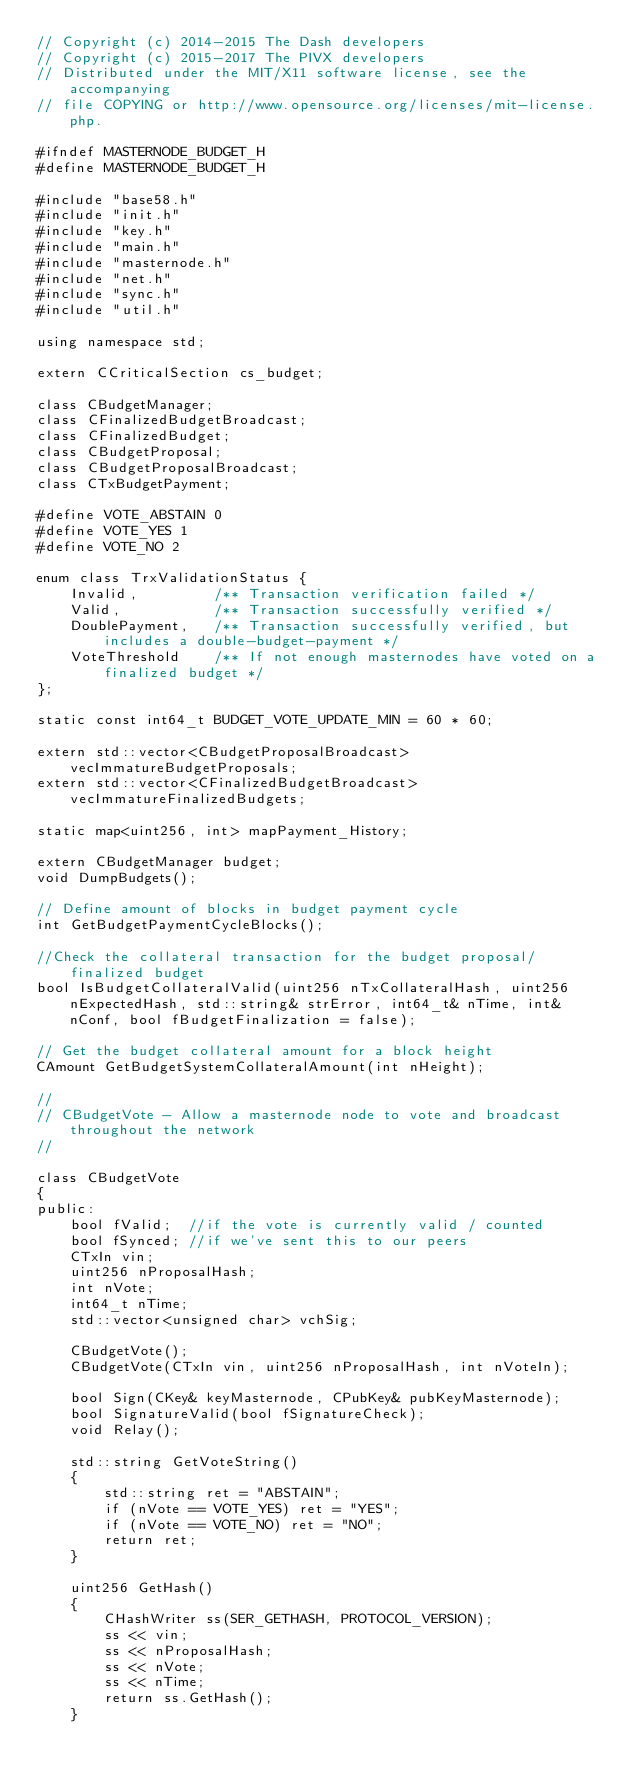<code> <loc_0><loc_0><loc_500><loc_500><_C_>// Copyright (c) 2014-2015 The Dash developers
// Copyright (c) 2015-2017 The PIVX developers
// Distributed under the MIT/X11 software license, see the accompanying
// file COPYING or http://www.opensource.org/licenses/mit-license.php.

#ifndef MASTERNODE_BUDGET_H
#define MASTERNODE_BUDGET_H

#include "base58.h"
#include "init.h"
#include "key.h"
#include "main.h"
#include "masternode.h"
#include "net.h"
#include "sync.h"
#include "util.h"

using namespace std;

extern CCriticalSection cs_budget;

class CBudgetManager;
class CFinalizedBudgetBroadcast;
class CFinalizedBudget;
class CBudgetProposal;
class CBudgetProposalBroadcast;
class CTxBudgetPayment;

#define VOTE_ABSTAIN 0
#define VOTE_YES 1
#define VOTE_NO 2

enum class TrxValidationStatus {
    Invalid,         /** Transaction verification failed */
    Valid,           /** Transaction successfully verified */
    DoublePayment,   /** Transaction successfully verified, but includes a double-budget-payment */
    VoteThreshold    /** If not enough masternodes have voted on a finalized budget */
};

static const int64_t BUDGET_VOTE_UPDATE_MIN = 60 * 60;

extern std::vector<CBudgetProposalBroadcast> vecImmatureBudgetProposals;
extern std::vector<CFinalizedBudgetBroadcast> vecImmatureFinalizedBudgets;

static map<uint256, int> mapPayment_History;

extern CBudgetManager budget;
void DumpBudgets();

// Define amount of blocks in budget payment cycle
int GetBudgetPaymentCycleBlocks();

//Check the collateral transaction for the budget proposal/finalized budget
bool IsBudgetCollateralValid(uint256 nTxCollateralHash, uint256 nExpectedHash, std::string& strError, int64_t& nTime, int& nConf, bool fBudgetFinalization = false);

// Get the budget collateral amount for a block height
CAmount GetBudgetSystemCollateralAmount(int nHeight);

//
// CBudgetVote - Allow a masternode node to vote and broadcast throughout the network
//

class CBudgetVote
{
public:
    bool fValid;  //if the vote is currently valid / counted
    bool fSynced; //if we've sent this to our peers
    CTxIn vin;
    uint256 nProposalHash;
    int nVote;
    int64_t nTime;
    std::vector<unsigned char> vchSig;

    CBudgetVote();
    CBudgetVote(CTxIn vin, uint256 nProposalHash, int nVoteIn);

    bool Sign(CKey& keyMasternode, CPubKey& pubKeyMasternode);
    bool SignatureValid(bool fSignatureCheck);
    void Relay();

    std::string GetVoteString()
    {
        std::string ret = "ABSTAIN";
        if (nVote == VOTE_YES) ret = "YES";
        if (nVote == VOTE_NO) ret = "NO";
        return ret;
    }

    uint256 GetHash()
    {
        CHashWriter ss(SER_GETHASH, PROTOCOL_VERSION);
        ss << vin;
        ss << nProposalHash;
        ss << nVote;
        ss << nTime;
        return ss.GetHash();
    }
</code> 